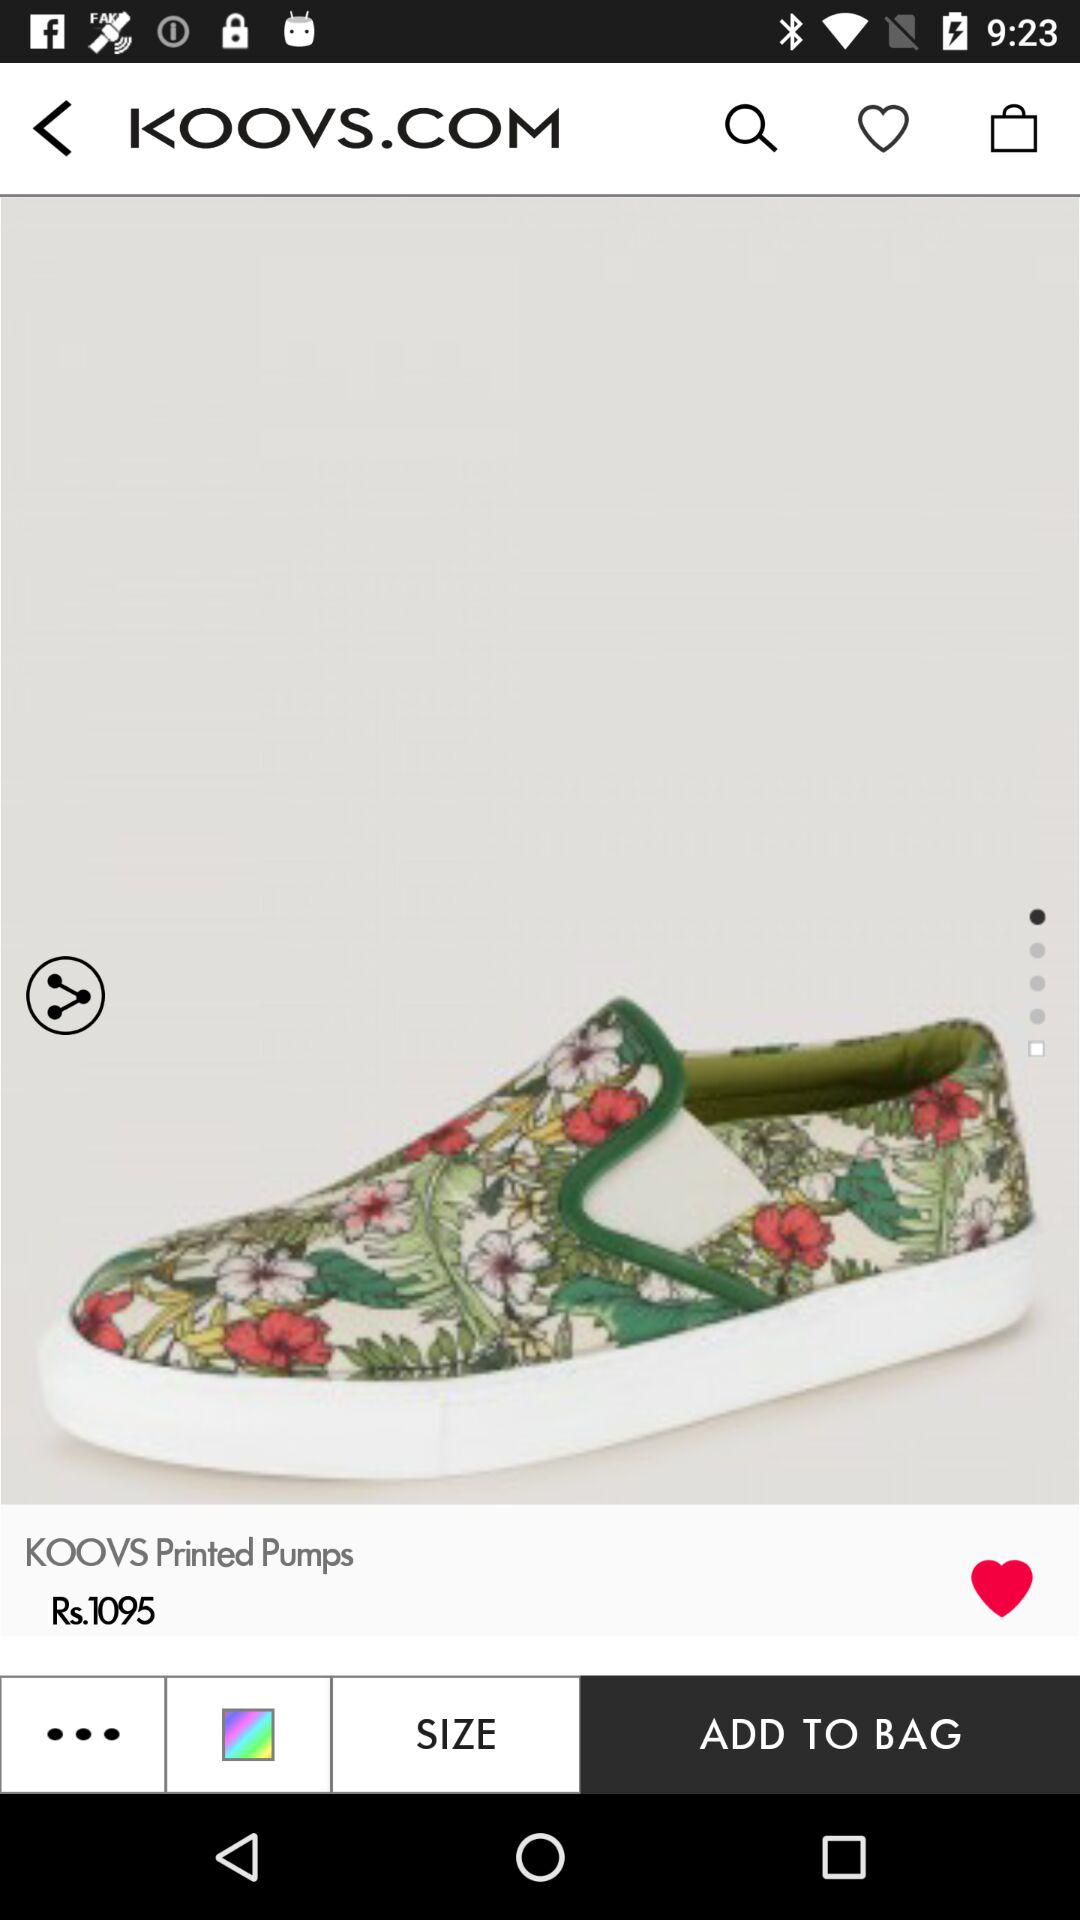How much is the product price?
Answer the question using a single word or phrase. Rs.1095 